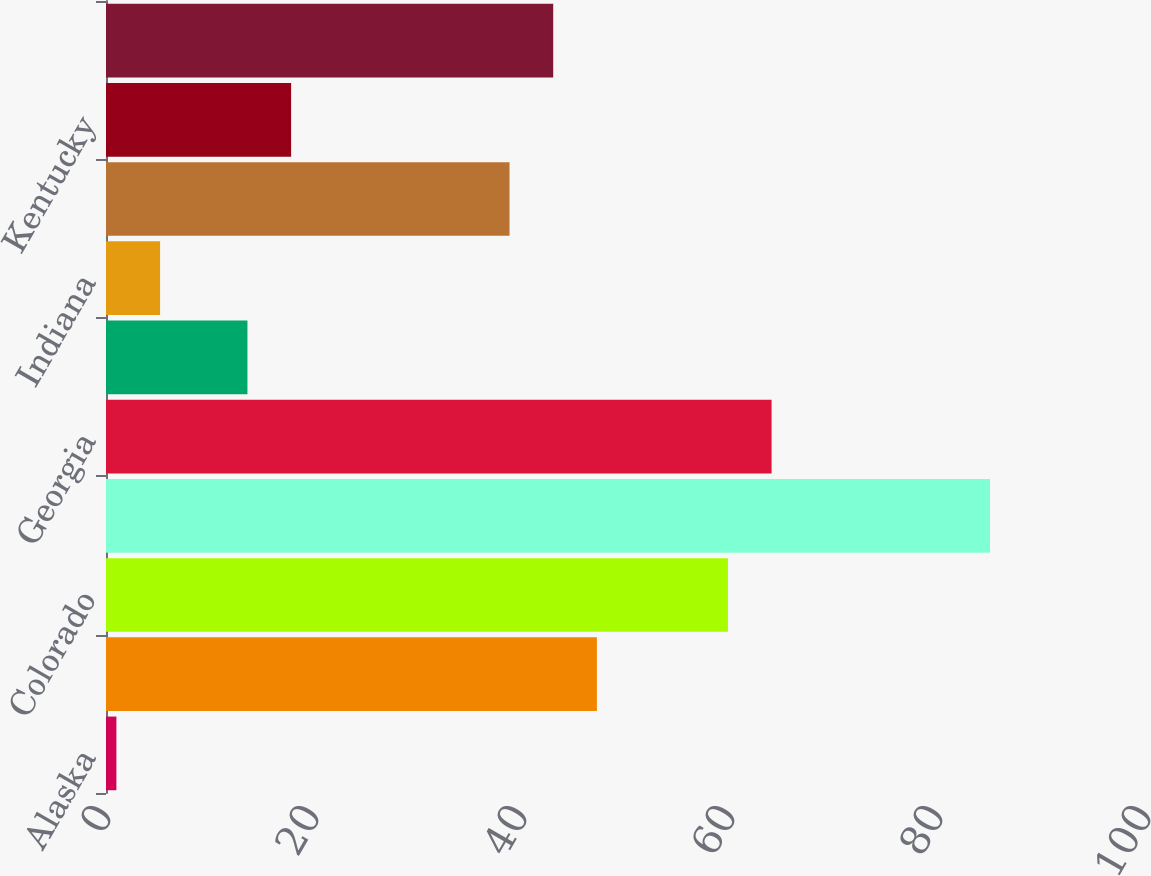Convert chart. <chart><loc_0><loc_0><loc_500><loc_500><bar_chart><fcel>Alaska<fcel>California<fcel>Colorado<fcel>Florida<fcel>Georgia<fcel>Idaho<fcel>Indiana<fcel>Kansas<fcel>Kentucky<fcel>Louisiana<nl><fcel>1<fcel>47.2<fcel>59.8<fcel>85<fcel>64<fcel>13.6<fcel>5.2<fcel>38.8<fcel>17.8<fcel>43<nl></chart> 